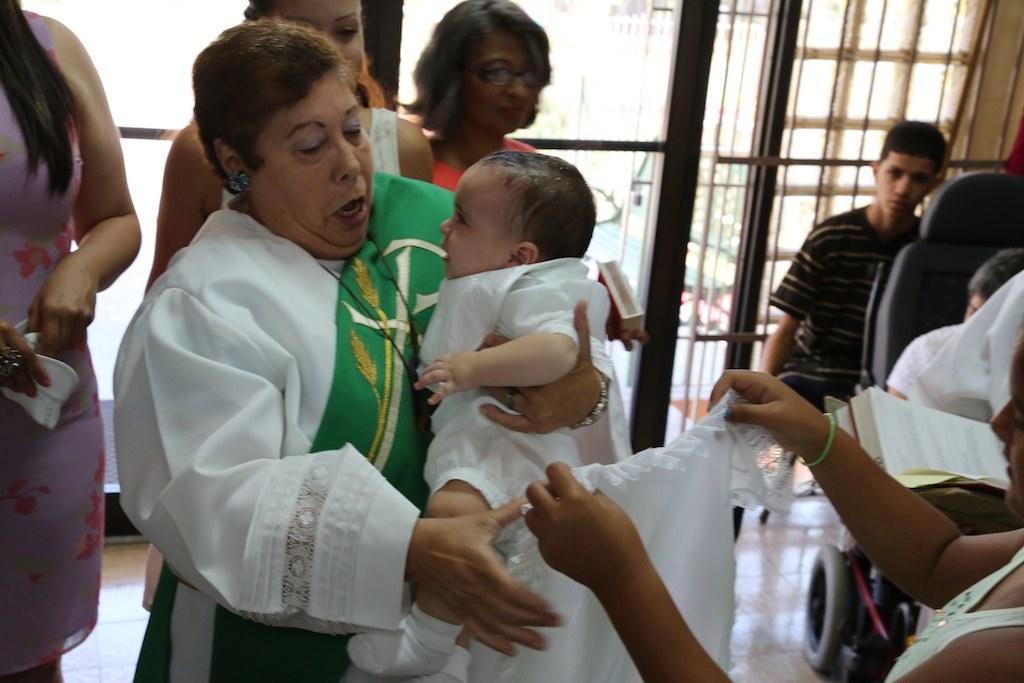Can you describe this image briefly? This picture describes about group of people, on the right side of the image we can see a person is sitting in the wheel chair and we can find few metal rods. 